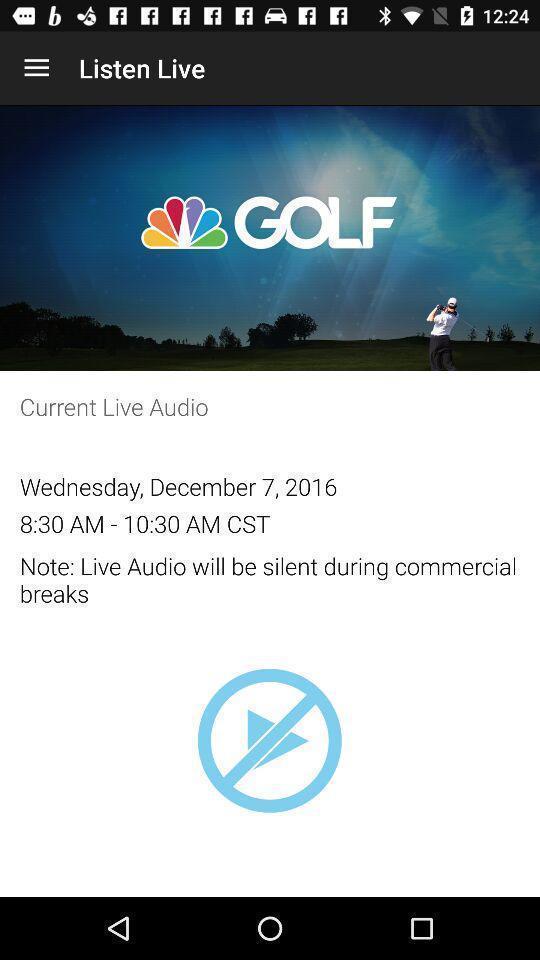Explain the elements present in this screenshot. Page showing details of a live audio event. 